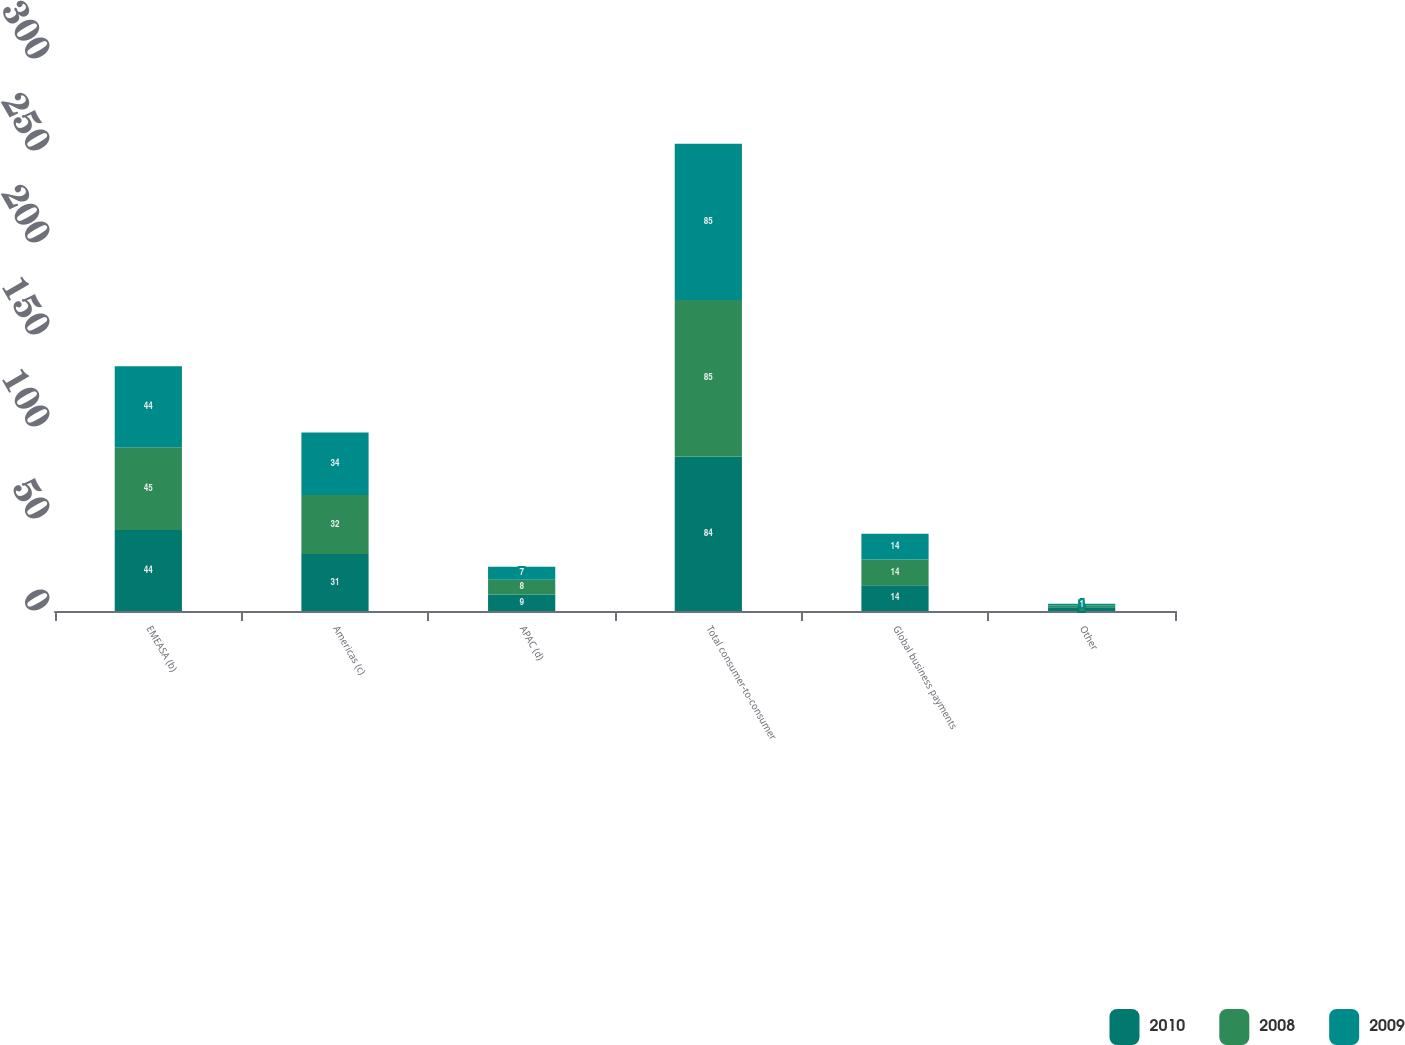Convert chart. <chart><loc_0><loc_0><loc_500><loc_500><stacked_bar_chart><ecel><fcel>EMEASA (b)<fcel>Americas (c)<fcel>APAC (d)<fcel>Total consumer-to-consumer<fcel>Global business payments<fcel>Other<nl><fcel>2010<fcel>44<fcel>31<fcel>9<fcel>84<fcel>14<fcel>2<nl><fcel>2008<fcel>45<fcel>32<fcel>8<fcel>85<fcel>14<fcel>1<nl><fcel>2009<fcel>44<fcel>34<fcel>7<fcel>85<fcel>14<fcel>1<nl></chart> 